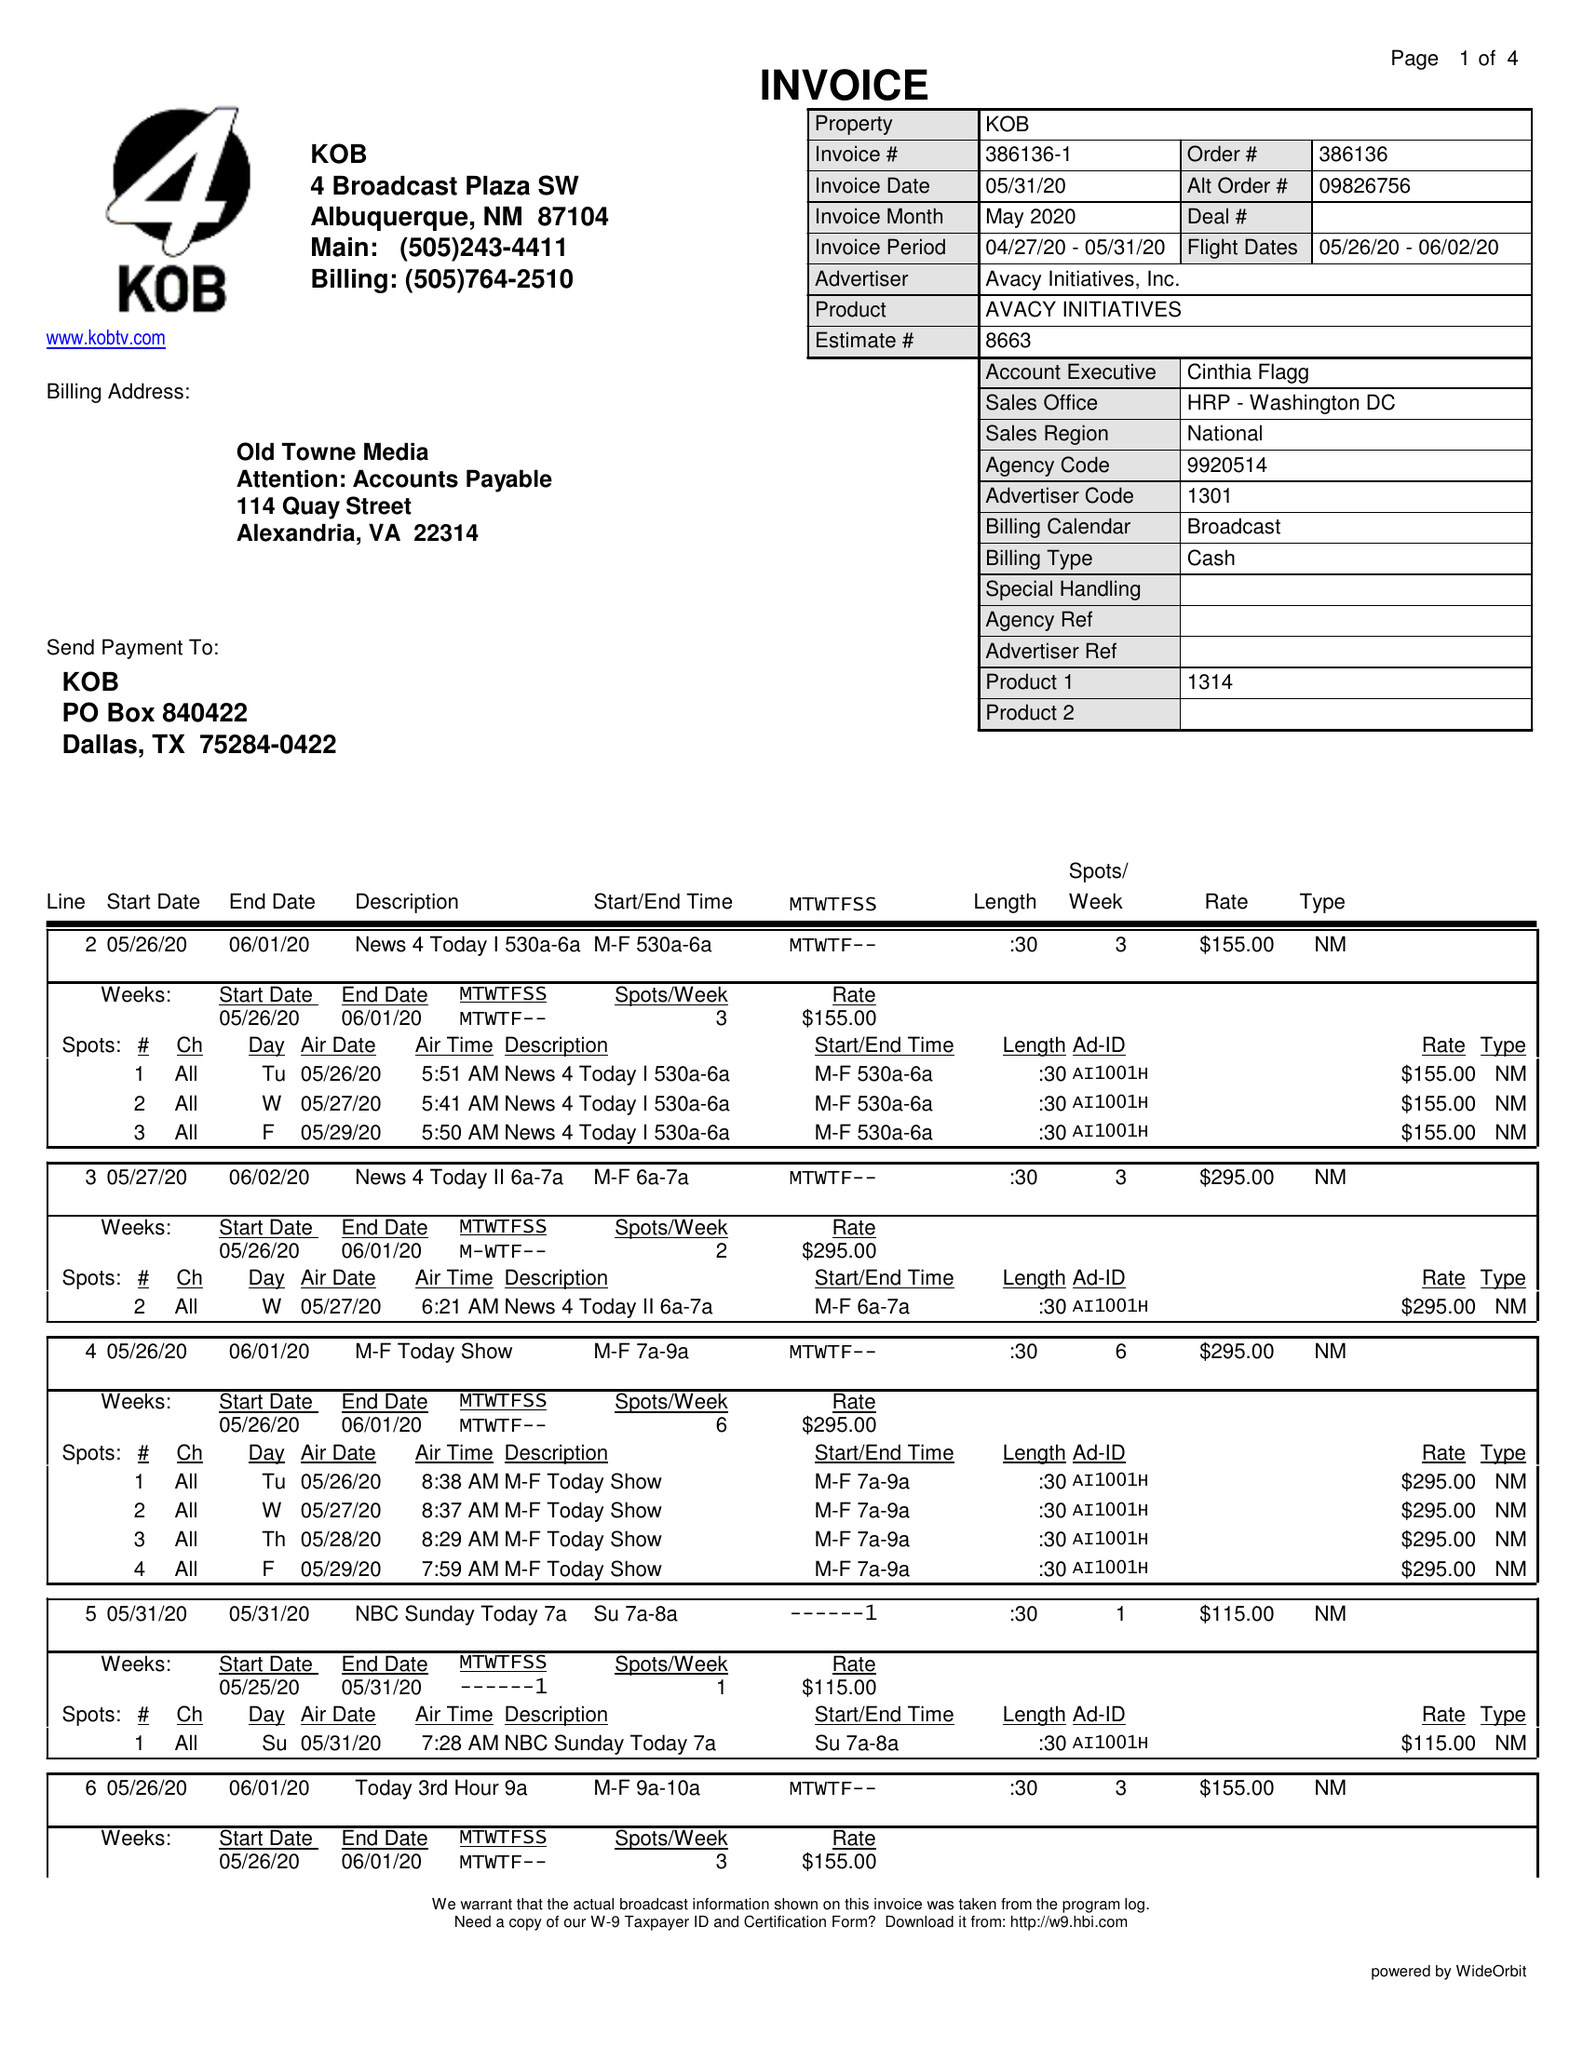What is the value for the flight_from?
Answer the question using a single word or phrase. 05/26/20 